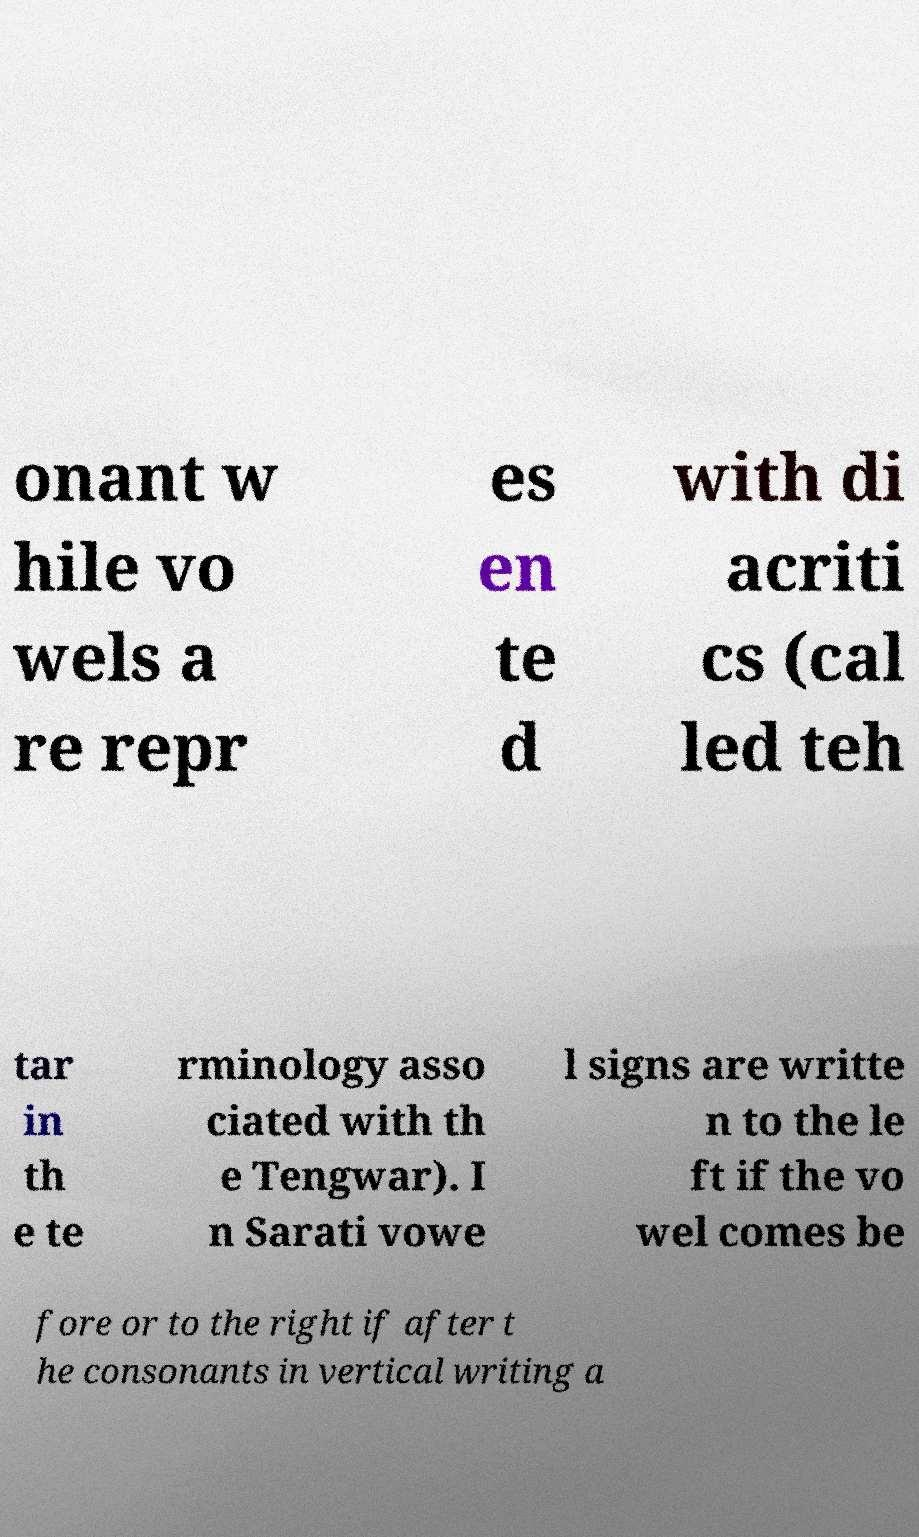Can you accurately transcribe the text from the provided image for me? onant w hile vo wels a re repr es en te d with di acriti cs (cal led teh tar in th e te rminology asso ciated with th e Tengwar). I n Sarati vowe l signs are writte n to the le ft if the vo wel comes be fore or to the right if after t he consonants in vertical writing a 